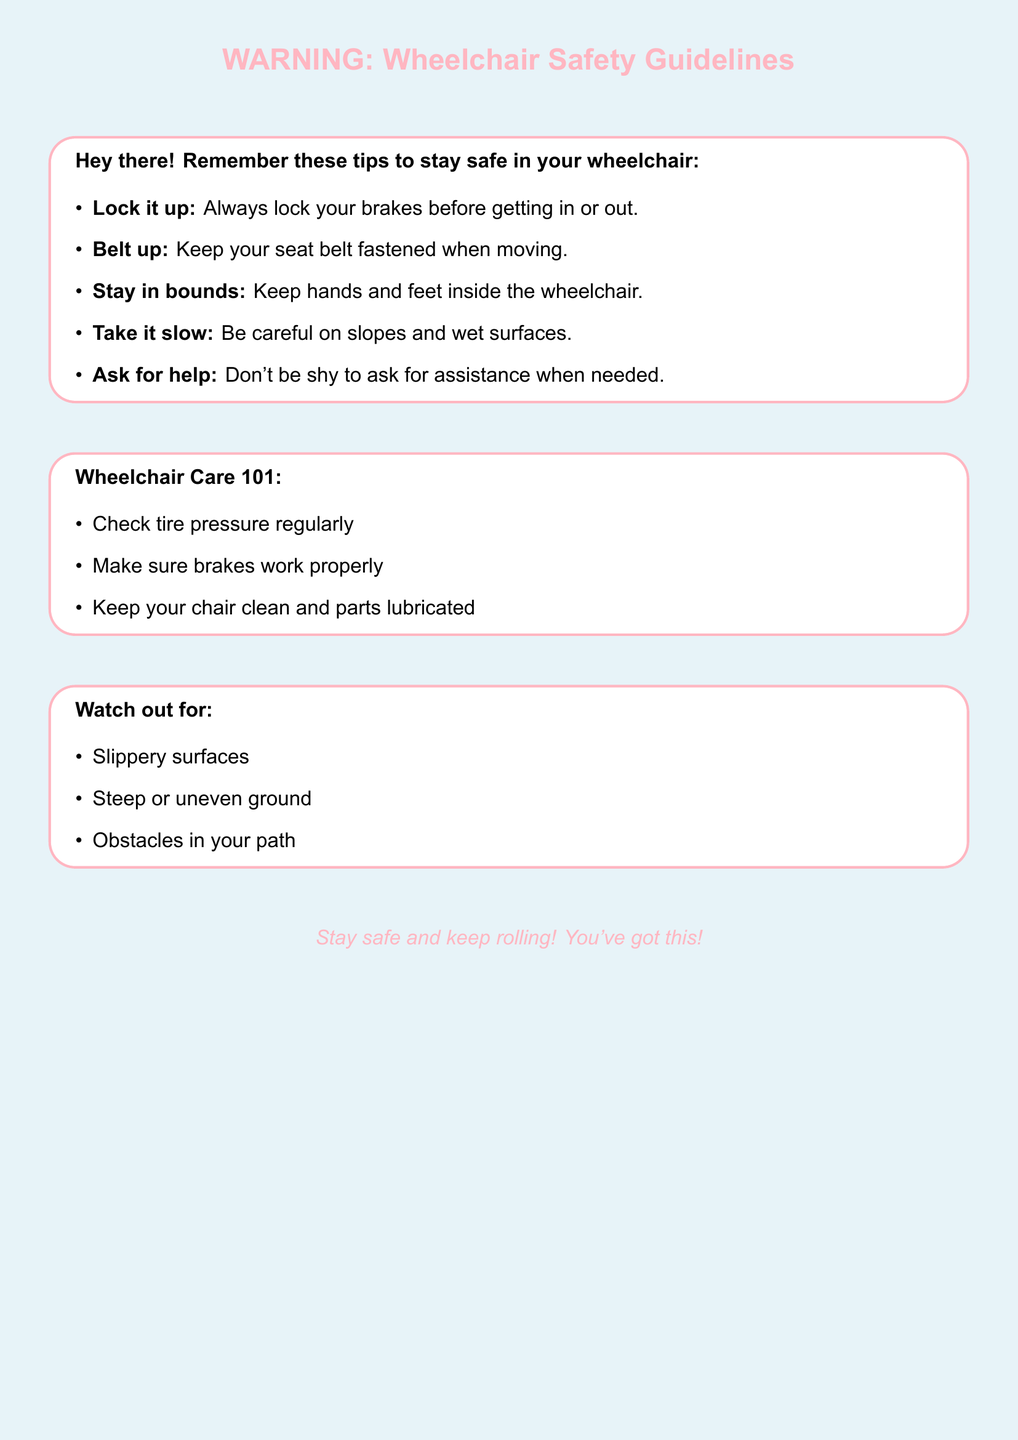What should you do before getting in or out of your wheelchair? The document advises to always lock the brakes before getting in or out of the wheelchair.
Answer: Lock your brakes What is recommended to wear while moving in your wheelchair? The document states to keep your seat belt fastened when moving for safety.
Answer: Seat belt What should you keep inside the wheelchair? The guideline mentions to keep hands and feet inside the wheelchair for safety.
Answer: Hands and feet What should you regularly check on your wheelchair? The document mentions checking tire pressure regularly as part of wheelchair care.
Answer: Tire pressure What surfaces should you be careful of according to the document? The document advises caution on slippery surfaces and steep or uneven ground.
Answer: Slippery surfaces Why is it important to ask for help? The document suggests not to be shy to ask for assistance when needed, implying safety is a priority.
Answer: Safety What type of obstacles should be watched out for while using a wheelchair? The document calls attention to obstacles in the path that can pose risks while using a wheelchair.
Answer: Obstacles What color is the background of the document? The document specifies a pastel blue background color.
Answer: Pastel blue What is the main message of the document? The document's main message encourages safe practices and keeping the user feeling empowered while using a wheelchair.
Answer: Stay safe and keep rolling! 